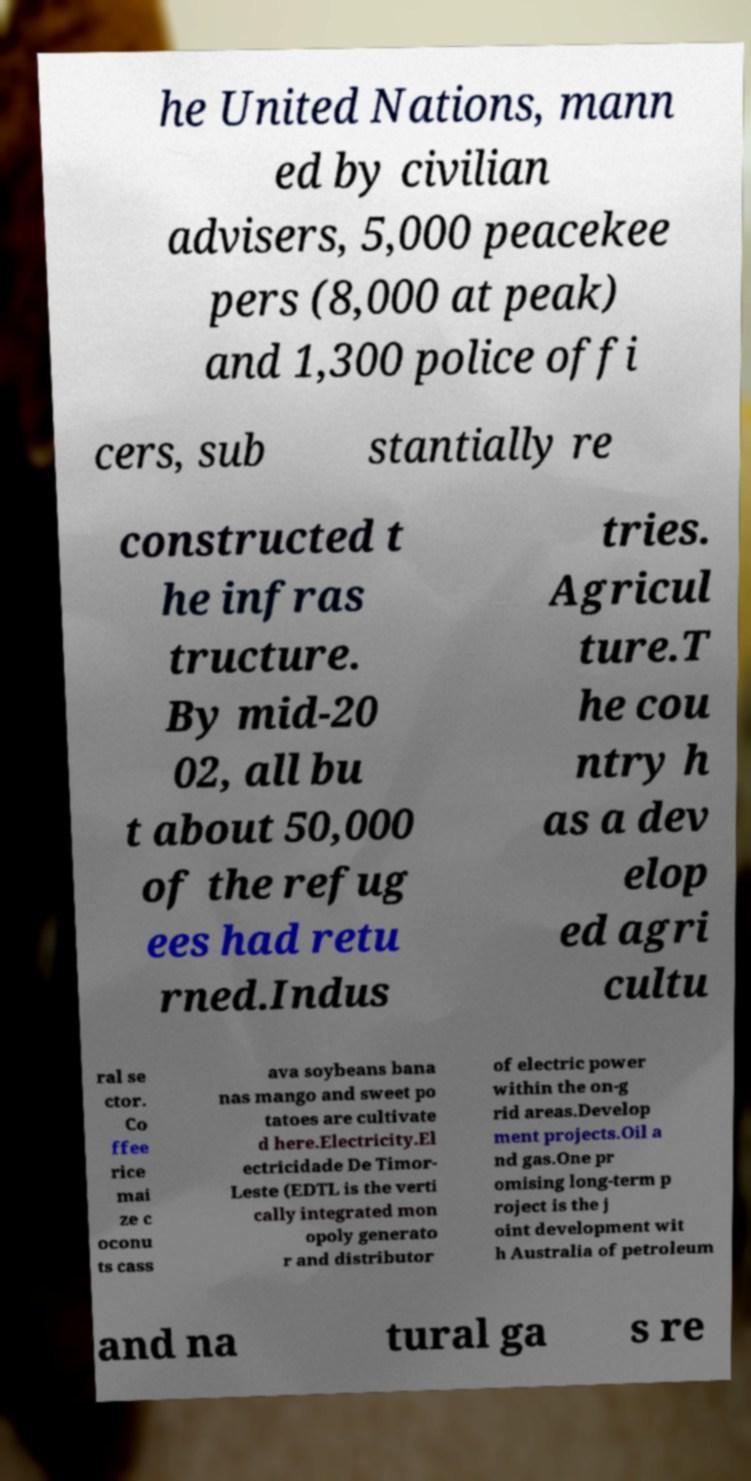What messages or text are displayed in this image? I need them in a readable, typed format. he United Nations, mann ed by civilian advisers, 5,000 peacekee pers (8,000 at peak) and 1,300 police offi cers, sub stantially re constructed t he infras tructure. By mid-20 02, all bu t about 50,000 of the refug ees had retu rned.Indus tries. Agricul ture.T he cou ntry h as a dev elop ed agri cultu ral se ctor. Co ffee rice mai ze c oconu ts cass ava soybeans bana nas mango and sweet po tatoes are cultivate d here.Electricity.El ectricidade De Timor- Leste (EDTL is the verti cally integrated mon opoly generato r and distributor of electric power within the on-g rid areas.Develop ment projects.Oil a nd gas.One pr omising long-term p roject is the j oint development wit h Australia of petroleum and na tural ga s re 